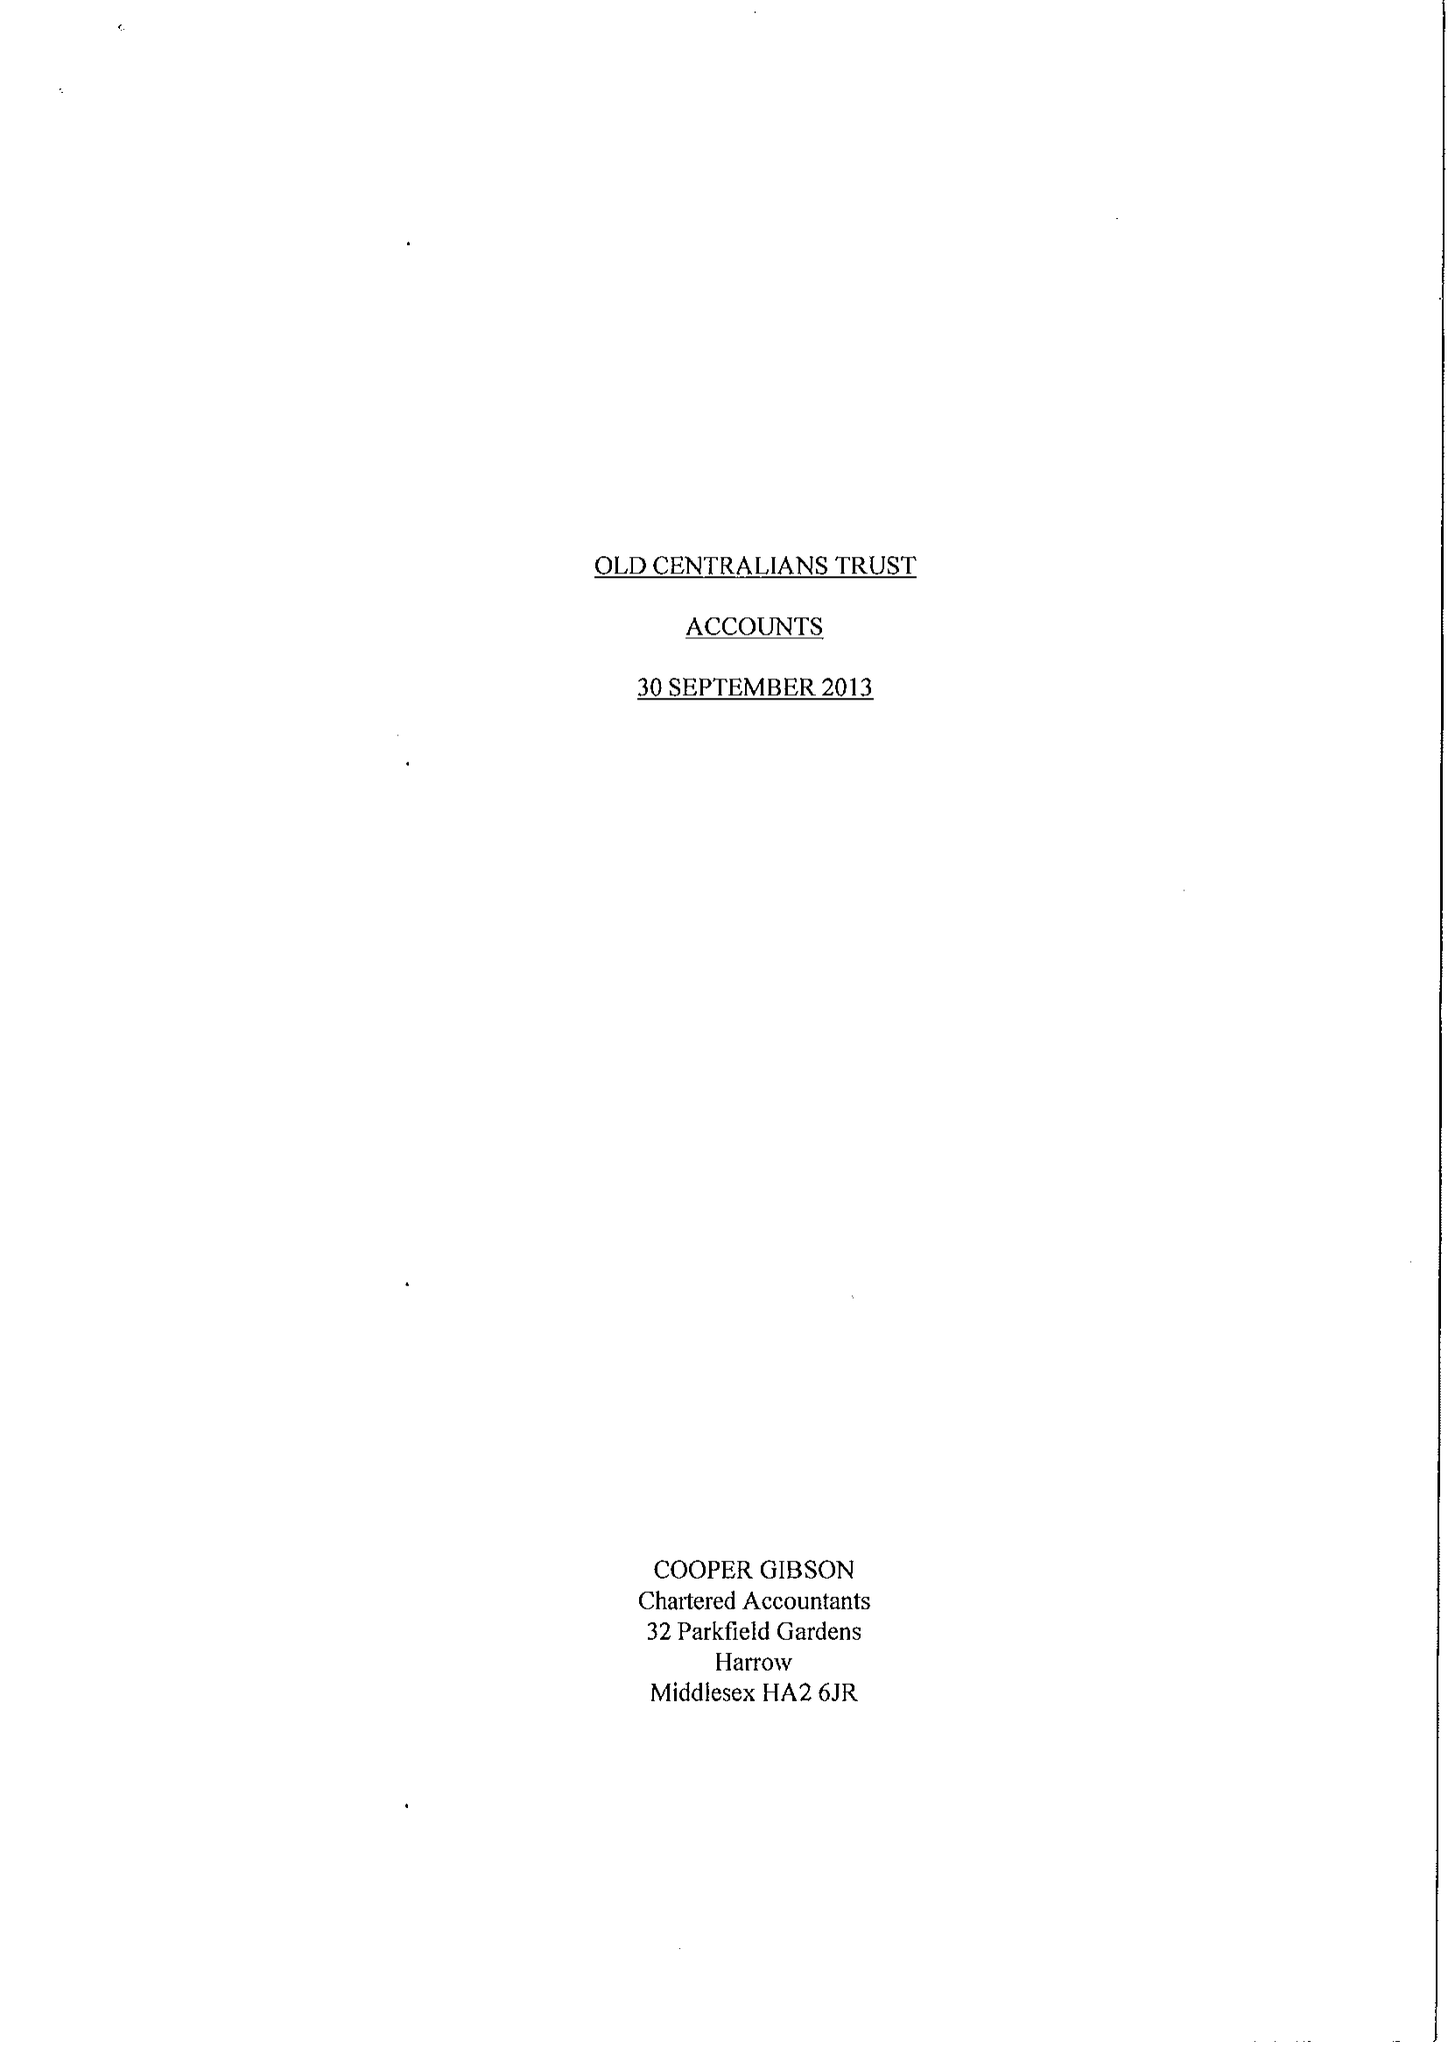What is the value for the report_date?
Answer the question using a single word or phrase. 2013-09-30 